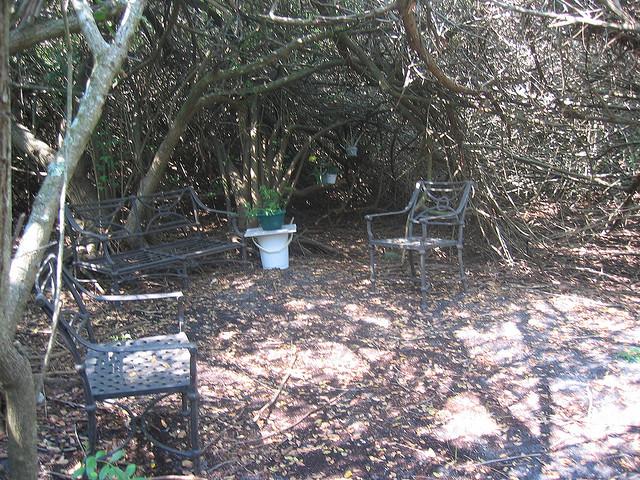Is this a shady spot?
Answer briefly. Yes. How many places are there to sit down?
Answer briefly. 3. What is the bench made out of?
Write a very short answer. Metal. 